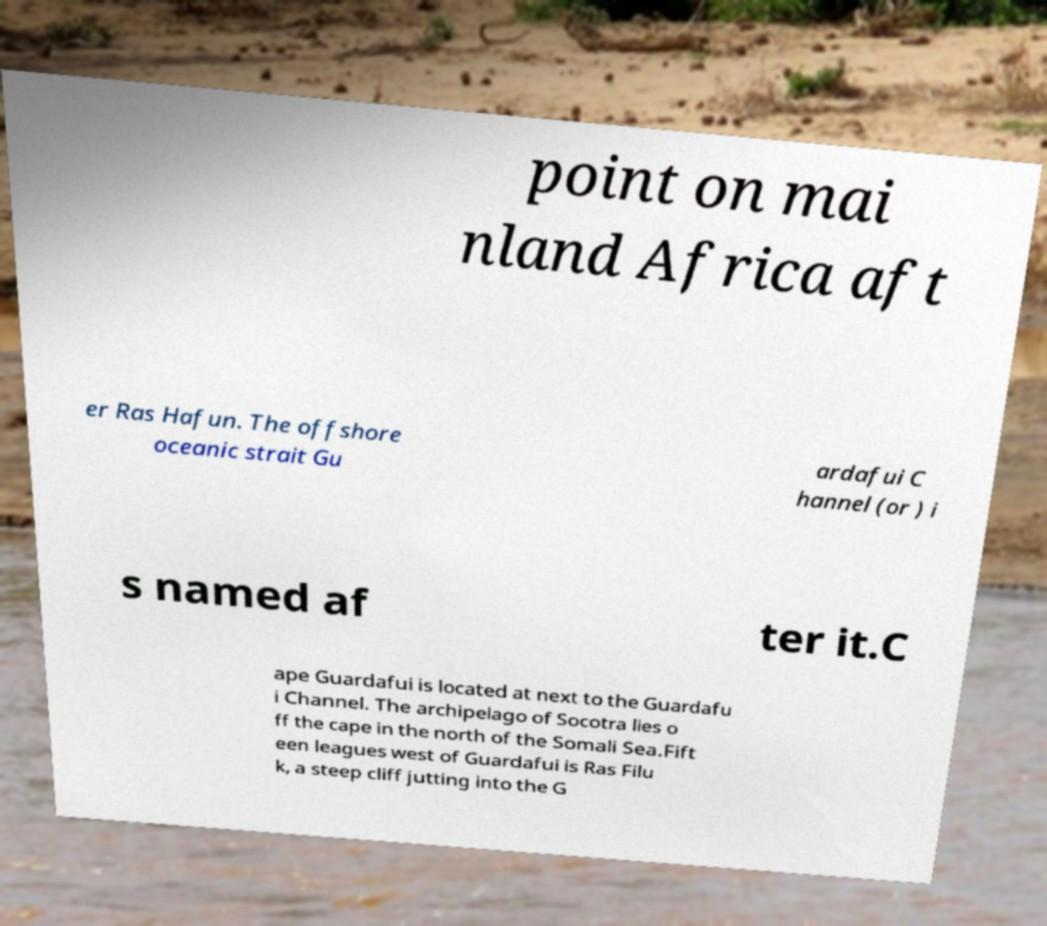Please read and relay the text visible in this image. What does it say? point on mai nland Africa aft er Ras Hafun. The offshore oceanic strait Gu ardafui C hannel (or ) i s named af ter it.C ape Guardafui is located at next to the Guardafu i Channel. The archipelago of Socotra lies o ff the cape in the north of the Somali Sea.Fift een leagues west of Guardafui is Ras Filu k, a steep cliff jutting into the G 